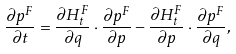<formula> <loc_0><loc_0><loc_500><loc_500>\frac { \partial p ^ { F } } { \partial t } = \frac { \partial H _ { t } ^ { F } } { \partial { q } } \cdot \frac { \partial p ^ { F } } { \partial { p } } - \frac { \partial H _ { t } ^ { F } } { \partial { p } } \cdot \frac { \partial p ^ { F } } { \partial { q } } ,</formula> 